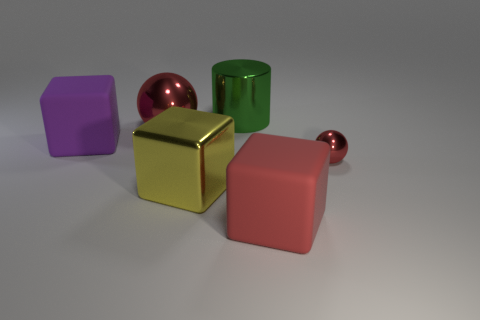How many other objects are there of the same color as the tiny ball?
Offer a terse response. 2. What number of other matte cubes are the same size as the red block?
Your response must be concise. 1. Is the number of red spheres that are behind the green object less than the number of tiny things in front of the small ball?
Make the answer very short. No. What size is the red metal thing in front of the matte cube that is on the left side of the red sphere behind the tiny thing?
Your response must be concise. Small. There is a thing that is both on the left side of the yellow object and on the right side of the purple matte object; what size is it?
Your response must be concise. Large. What is the shape of the large object that is behind the shiny sphere to the left of the big shiny cylinder?
Offer a terse response. Cylinder. Are there any other things that have the same color as the cylinder?
Make the answer very short. No. What is the shape of the rubber object that is in front of the tiny red object?
Your response must be concise. Cube. What shape is the shiny thing that is both on the right side of the big yellow metallic cube and behind the purple object?
Offer a very short reply. Cylinder. How many yellow things are large blocks or metallic things?
Your answer should be very brief. 1. 